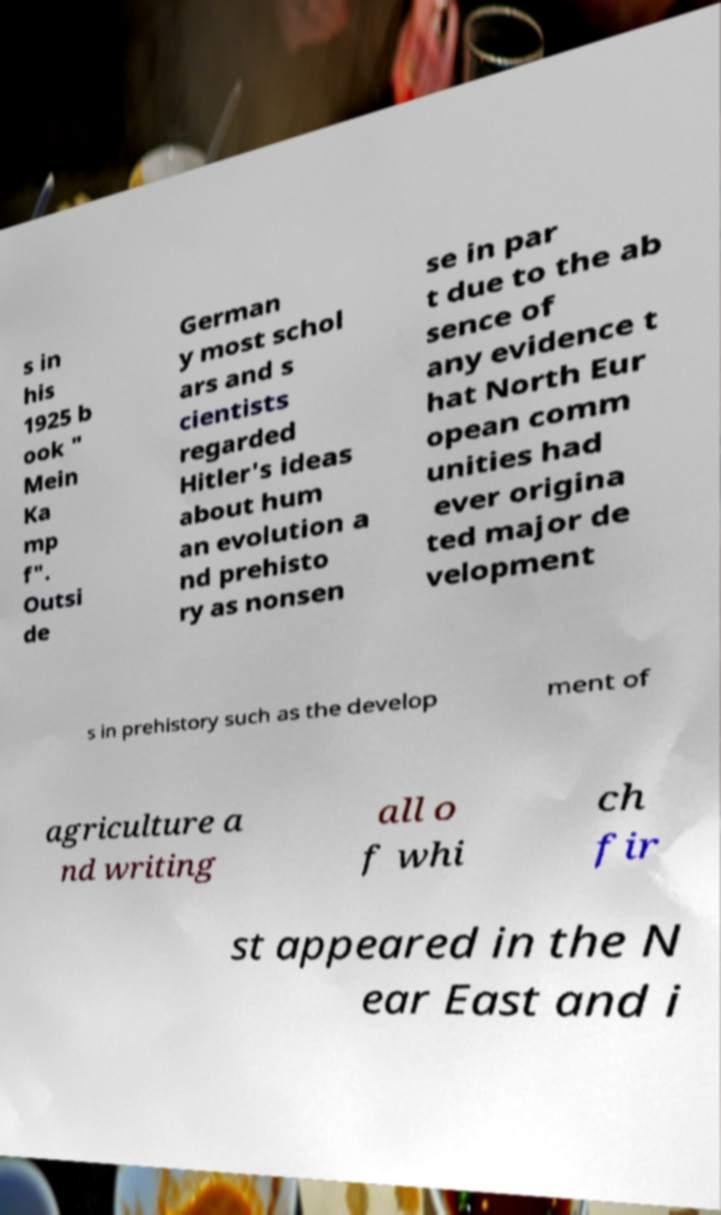There's text embedded in this image that I need extracted. Can you transcribe it verbatim? s in his 1925 b ook " Mein Ka mp f". Outsi de German y most schol ars and s cientists regarded Hitler's ideas about hum an evolution a nd prehisto ry as nonsen se in par t due to the ab sence of any evidence t hat North Eur opean comm unities had ever origina ted major de velopment s in prehistory such as the develop ment of agriculture a nd writing all o f whi ch fir st appeared in the N ear East and i 